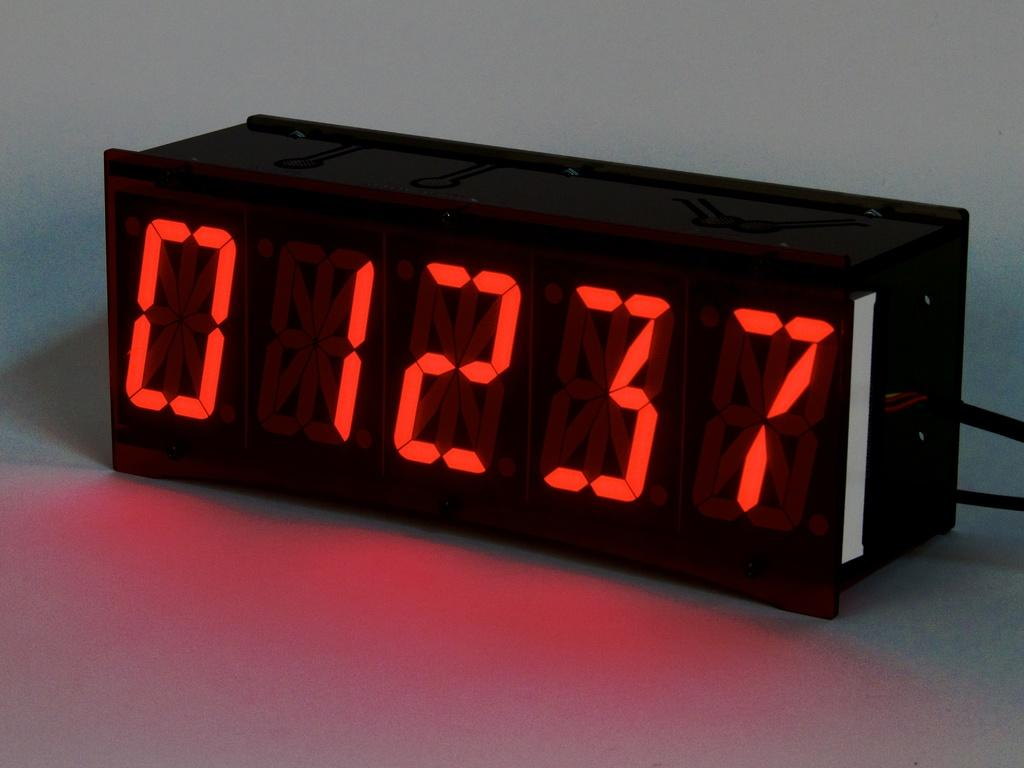Provide a one-sentence caption for the provided image. a black digital clock with red letters displaying 01237. 